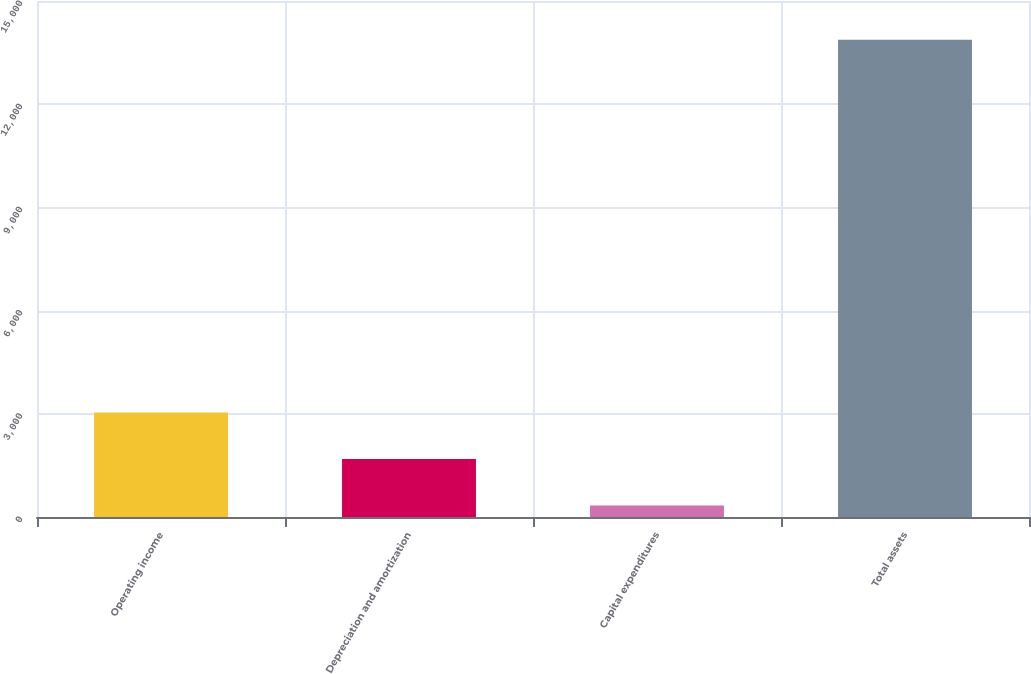<chart> <loc_0><loc_0><loc_500><loc_500><bar_chart><fcel>Operating income<fcel>Depreciation and amortization<fcel>Capital expenditures<fcel>Total assets<nl><fcel>3039.42<fcel>1685.56<fcel>331.7<fcel>13870.3<nl></chart> 